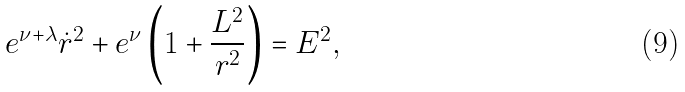Convert formula to latex. <formula><loc_0><loc_0><loc_500><loc_500>e ^ { \nu + \lambda } \dot { r } ^ { 2 } + e ^ { \nu } \left ( 1 + \frac { L ^ { 2 } } { r ^ { 2 } } \right ) = E ^ { 2 } ,</formula> 